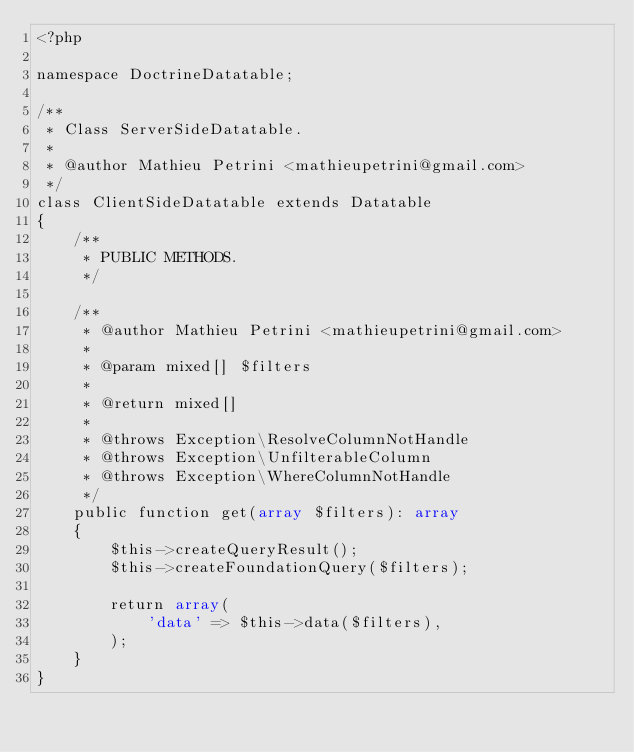<code> <loc_0><loc_0><loc_500><loc_500><_PHP_><?php

namespace DoctrineDatatable;

/**
 * Class ServerSideDatatable.
 *
 * @author Mathieu Petrini <mathieupetrini@gmail.com>
 */
class ClientSideDatatable extends Datatable
{
    /**
     * PUBLIC METHODS.
     */

    /**
     * @author Mathieu Petrini <mathieupetrini@gmail.com>
     *
     * @param mixed[] $filters
     *
     * @return mixed[]
     *
     * @throws Exception\ResolveColumnNotHandle
     * @throws Exception\UnfilterableColumn
     * @throws Exception\WhereColumnNotHandle
     */
    public function get(array $filters): array
    {
        $this->createQueryResult();
        $this->createFoundationQuery($filters);

        return array(
            'data' => $this->data($filters),
        );
    }
}
</code> 